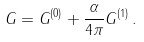Convert formula to latex. <formula><loc_0><loc_0><loc_500><loc_500>G = G ^ { ( 0 ) } + \frac { \alpha } { 4 \pi } G ^ { ( 1 ) } \, .</formula> 